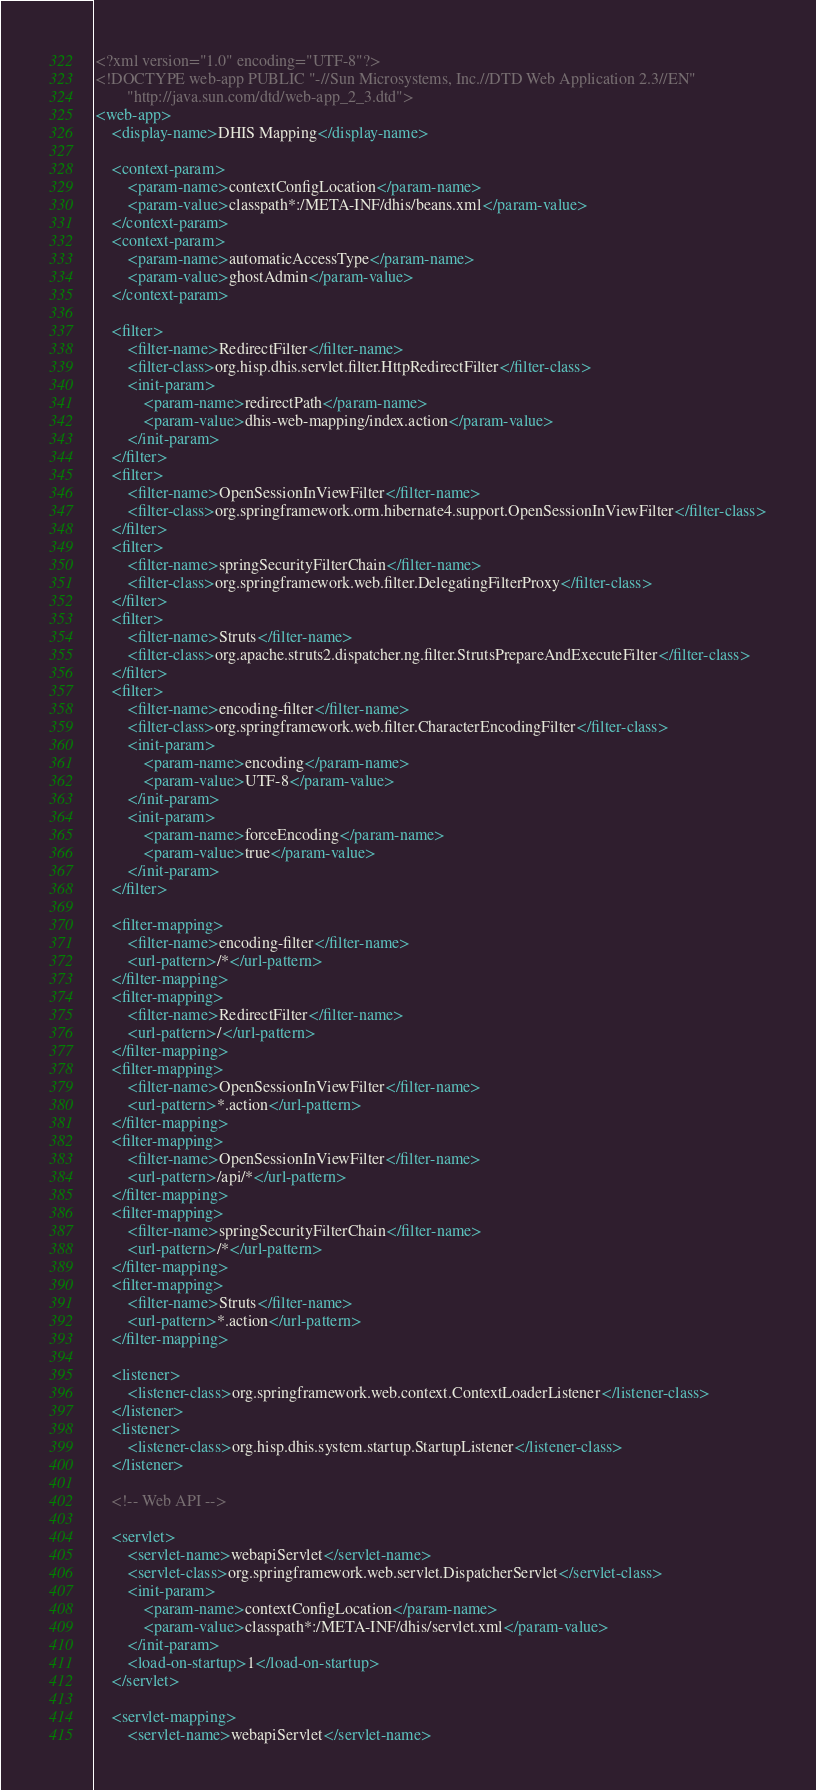<code> <loc_0><loc_0><loc_500><loc_500><_XML_><?xml version="1.0" encoding="UTF-8"?>
<!DOCTYPE web-app PUBLIC "-//Sun Microsystems, Inc.//DTD Web Application 2.3//EN"
        "http://java.sun.com/dtd/web-app_2_3.dtd">
<web-app>
    <display-name>DHIS Mapping</display-name>

    <context-param>
        <param-name>contextConfigLocation</param-name>
        <param-value>classpath*:/META-INF/dhis/beans.xml</param-value>
    </context-param>
    <context-param>
        <param-name>automaticAccessType</param-name>
        <param-value>ghostAdmin</param-value>
    </context-param>

    <filter>
        <filter-name>RedirectFilter</filter-name>
        <filter-class>org.hisp.dhis.servlet.filter.HttpRedirectFilter</filter-class>
        <init-param>
            <param-name>redirectPath</param-name>
            <param-value>dhis-web-mapping/index.action</param-value>
        </init-param>
    </filter>
    <filter>
        <filter-name>OpenSessionInViewFilter</filter-name>
        <filter-class>org.springframework.orm.hibernate4.support.OpenSessionInViewFilter</filter-class>
    </filter>
    <filter>
        <filter-name>springSecurityFilterChain</filter-name>
        <filter-class>org.springframework.web.filter.DelegatingFilterProxy</filter-class>
    </filter>
    <filter>
        <filter-name>Struts</filter-name>
        <filter-class>org.apache.struts2.dispatcher.ng.filter.StrutsPrepareAndExecuteFilter</filter-class>
    </filter>
    <filter>
        <filter-name>encoding-filter</filter-name>
        <filter-class>org.springframework.web.filter.CharacterEncodingFilter</filter-class>
        <init-param>
            <param-name>encoding</param-name>
            <param-value>UTF-8</param-value>
        </init-param>
        <init-param>
            <param-name>forceEncoding</param-name>
            <param-value>true</param-value>
        </init-param>
    </filter>

    <filter-mapping>
        <filter-name>encoding-filter</filter-name>
        <url-pattern>/*</url-pattern>
    </filter-mapping>
    <filter-mapping>
        <filter-name>RedirectFilter</filter-name>
        <url-pattern>/</url-pattern>
    </filter-mapping>
    <filter-mapping>
        <filter-name>OpenSessionInViewFilter</filter-name>
        <url-pattern>*.action</url-pattern>
    </filter-mapping>
    <filter-mapping>
        <filter-name>OpenSessionInViewFilter</filter-name>
        <url-pattern>/api/*</url-pattern>
    </filter-mapping>
    <filter-mapping>
        <filter-name>springSecurityFilterChain</filter-name>
        <url-pattern>/*</url-pattern>
    </filter-mapping>
    <filter-mapping>
        <filter-name>Struts</filter-name>
        <url-pattern>*.action</url-pattern>
    </filter-mapping>

    <listener>
        <listener-class>org.springframework.web.context.ContextLoaderListener</listener-class>
    </listener>
    <listener>
        <listener-class>org.hisp.dhis.system.startup.StartupListener</listener-class>
    </listener>

    <!-- Web API -->

    <servlet>
        <servlet-name>webapiServlet</servlet-name>
        <servlet-class>org.springframework.web.servlet.DispatcherServlet</servlet-class>
        <init-param>
            <param-name>contextConfigLocation</param-name>
            <param-value>classpath*:/META-INF/dhis/servlet.xml</param-value>
        </init-param>
        <load-on-startup>1</load-on-startup>
    </servlet>

    <servlet-mapping>
        <servlet-name>webapiServlet</servlet-name></code> 